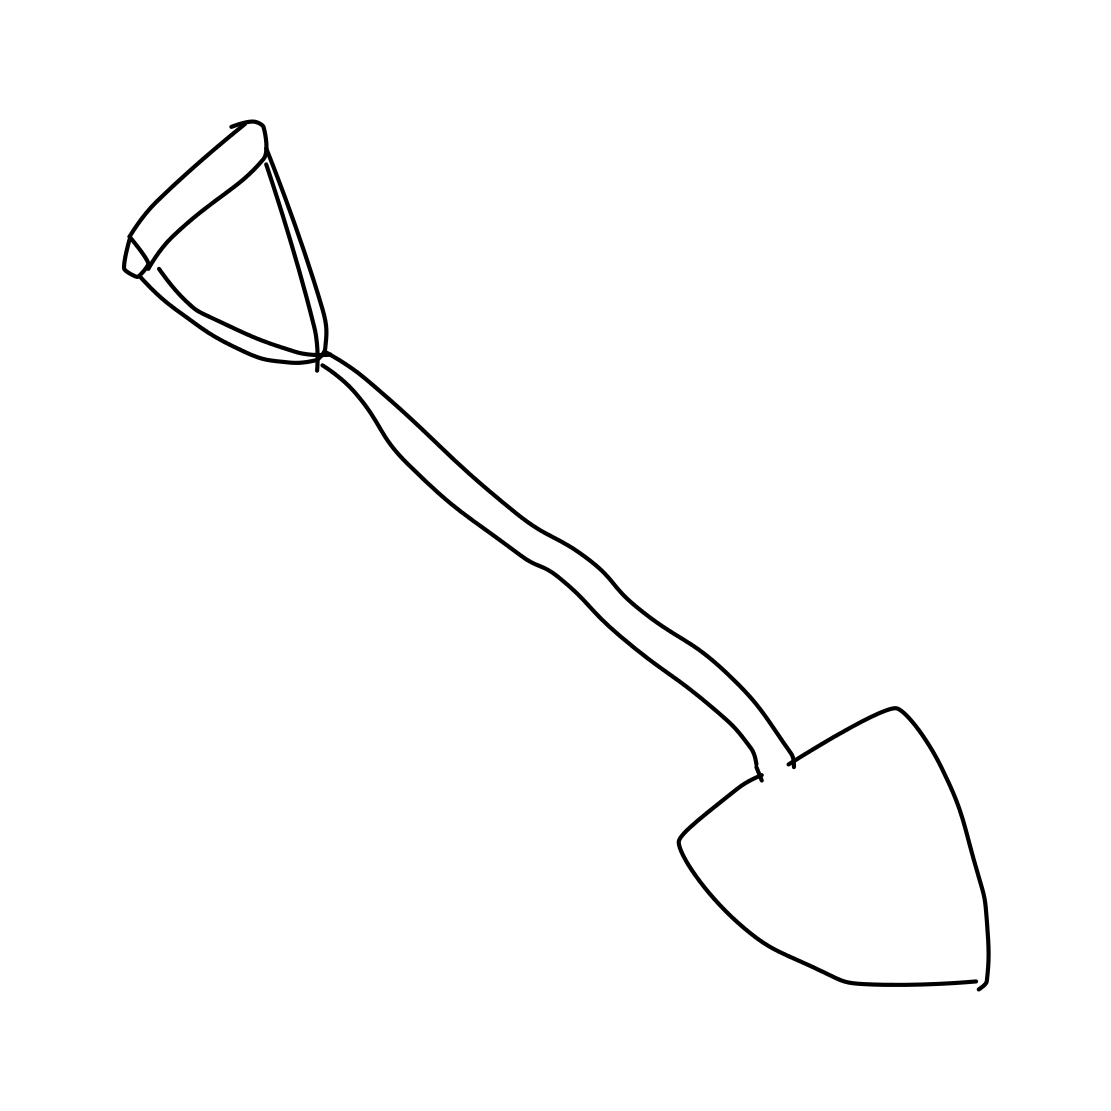Could this shovel be part of a larger set of tools in a collection? It's possible. This shovel might be one among various tools in a set, perhaps outlined in a similar sketchy style, that together would form a kit essential for gardening or construction activities. What other tools might be included in such a set? Typically, a comprehensive gardening set might include a rake, a hoe, pruning shears, a trowel, and sometimes more specialized tools like a cultivator or a weed puller, all designed to assist in different tasks around the garden. 